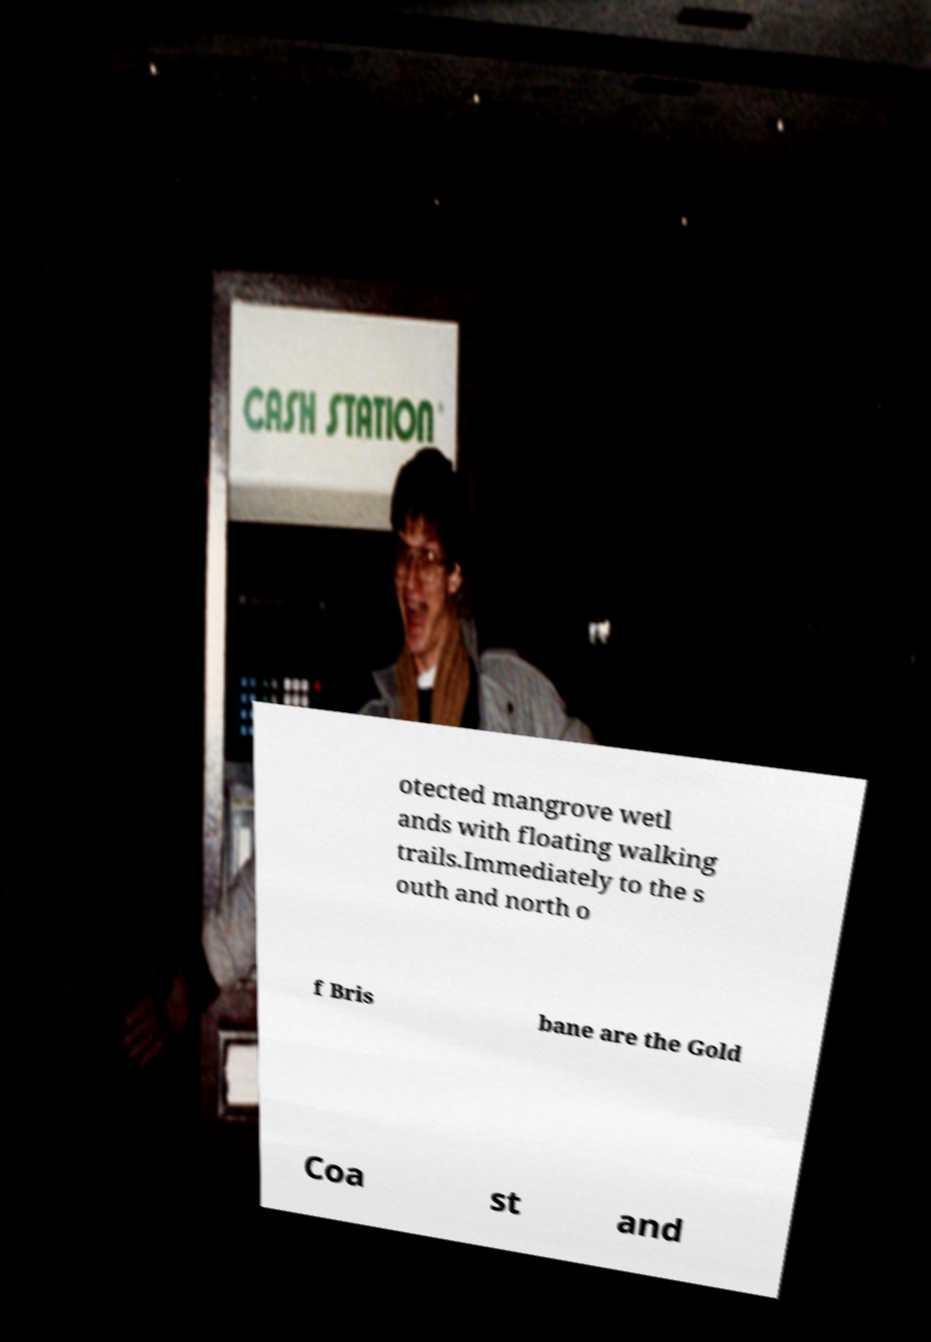What messages or text are displayed in this image? I need them in a readable, typed format. otected mangrove wetl ands with floating walking trails.Immediately to the s outh and north o f Bris bane are the Gold Coa st and 